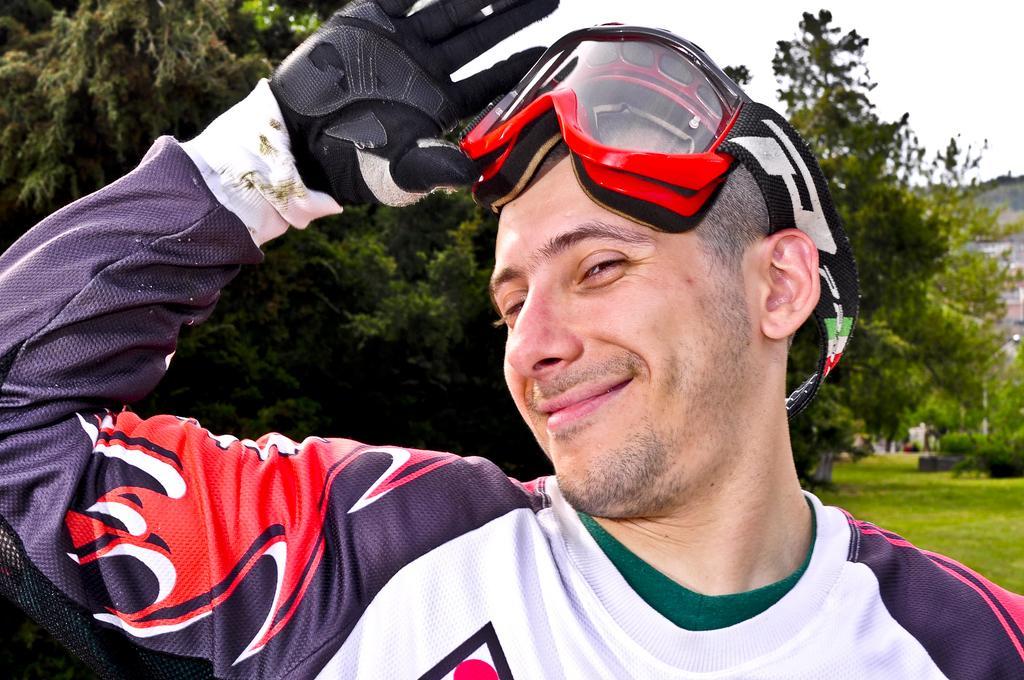In one or two sentences, can you explain what this image depicts? In the picture we can see a man standing, he is wearing a T-shirt with a black glove and glasses and in the background we can see a grass, trees, and hill. 